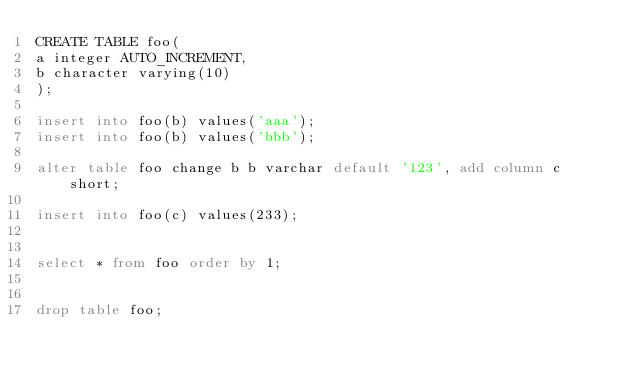Convert code to text. <code><loc_0><loc_0><loc_500><loc_500><_SQL_>CREATE TABLE foo(
a integer AUTO_INCREMENT,
b character varying(10)
);

insert into foo(b) values('aaa');
insert into foo(b) values('bbb');

alter table foo change b b varchar default '123', add column c short;

insert into foo(c) values(233);


select * from foo order by 1;


drop table foo;


</code> 